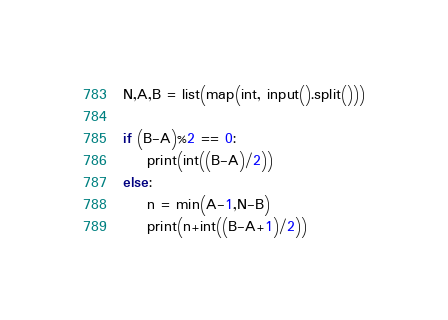Convert code to text. <code><loc_0><loc_0><loc_500><loc_500><_Python_>N,A,B = list(map(int, input().split()))

if (B-A)%2 == 0:
    print(int((B-A)/2))
else:
    n = min(A-1,N-B)
    print(n+int((B-A+1)/2))
</code> 